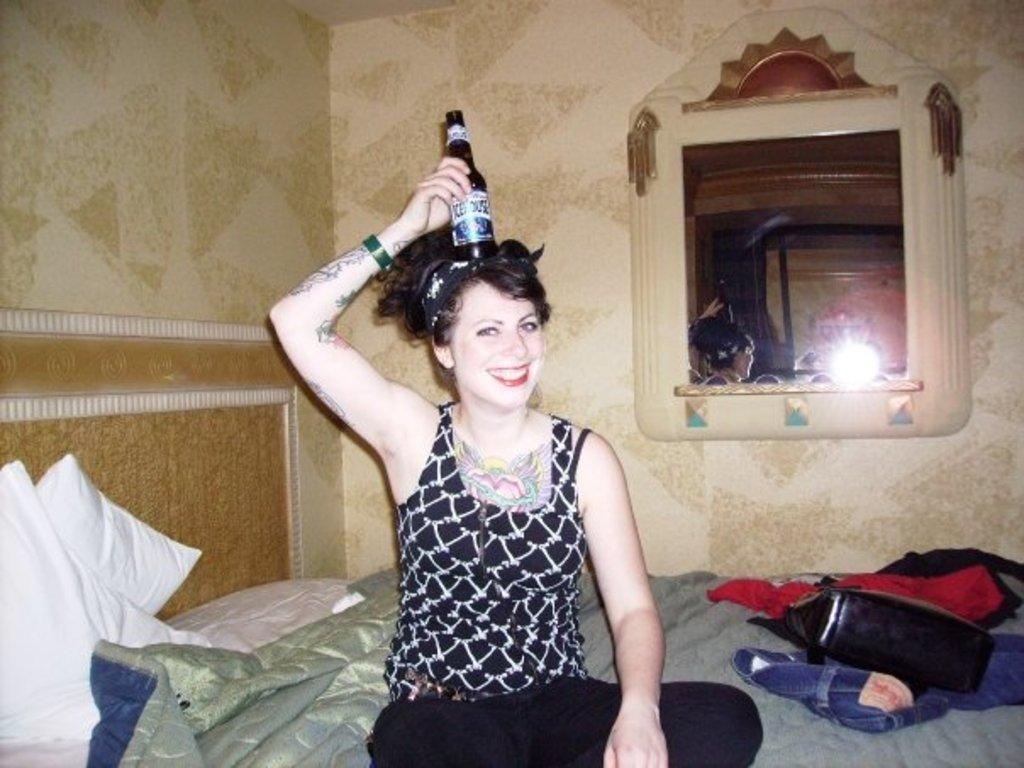Could you give a brief overview of what you see in this image? In this picture I can see there is a woman and she is wearing a black dress and a black pant. She is smiling and holding a wine bottle and placed it on her head. There is a handbag, shirt and pant placed on the bed and there is a blanket and pillows here at right side. There is a wall on to left. 